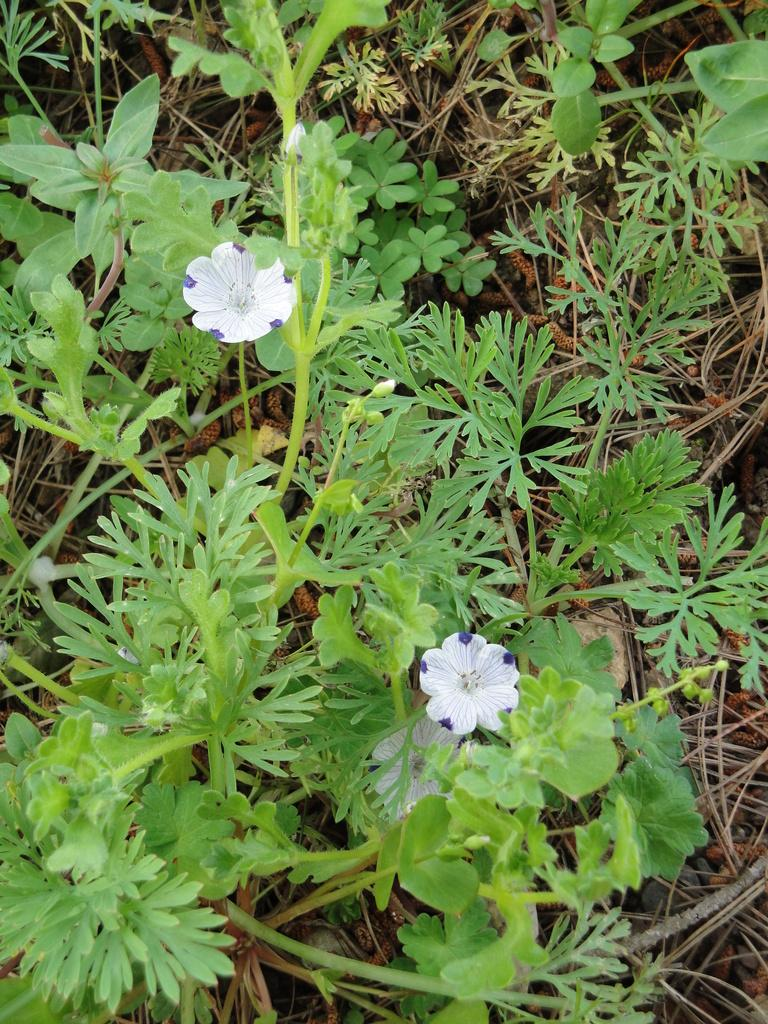What colors are the flowers in the image? The flowers in the image are white and purple. What type of plants are present in the image besides flowers? There are green plants in the image. What type of street is visible in the image? There is no street present in the image; it features flowers and green plants. What type of pleasure can be derived from the image? The image is not intended to provide pleasure; it is a simple depiction of flowers and green plants. 